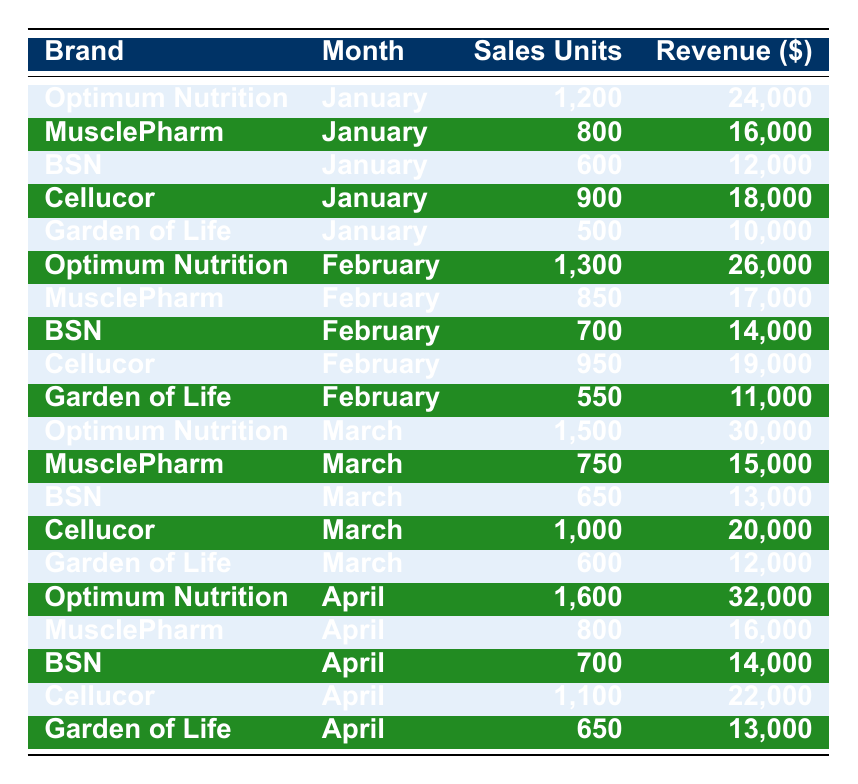What was the highest sales units for Optimum Nutrition? Looking through the table for Optimum Nutrition, the highest sales units were recorded in April with 1600 units sold.
Answer: 1600 What is the total revenue generated by MusclePharm in January and February? For January, MusclePharm's revenue was 16000 and in February it was 17000. Adding these together gives: 16000 + 17000 = 33000.
Answer: 33000 Did BSN have sales units over 700 in any month? By reviewing the table, BSN had sales units of 700 in April, which meets the criteria of being over 700.
Answer: Yes What was the average sales units for Garden of Life over the four months? To find the average, we sum the sales units for Garden of Life: 500 (Jan) + 550 (Feb) + 600 (Mar) + 650 (Apr) = 2300. There are 4 months, so the average is 2300/4 = 575.
Answer: 575 In March, which brand had the highest revenue? In March, the revenues for each brand are: Optimum Nutrition: 30000, MusclePharm: 15000, BSN: 13000, Cellucor: 20000, and Garden of Life: 12000. The highest revenue is from Optimum Nutrition at 30000.
Answer: 30000 Which brand consistently had the lowest sales units over the four months? Reviewing the sales units per brand, Garden of Life consistently shows the lowest numbers: 500, 550, 600, and 650 units sold for the four months respectively.
Answer: Garden of Life How much more revenue did Cellucor generate in April compared to January? Cellucor's revenue in April was 22000, and in January it was 18000. The difference is 22000 - 18000 = 4000, indicating that Cellucor generated 4000 more in April than January.
Answer: 4000 What percentage of total sales units for February came from Optimum Nutrition? Optimum Nutrition had 1300 units in February, and the total sales units for February across all brands is 1300 + 850 + 700 + 950 + 550 = 4300. To find the percentage: (1300/4300) * 100 = 30.23%.
Answer: 30.23% Did Garden of Life's revenue ever exceed 13000 in any month? Checking the revenue for Garden of Life, we find the amounts: 10000 in January, 11000 in February, 12000 in March, and 13000 in April. It did exceed 13000 only in April.
Answer: No 